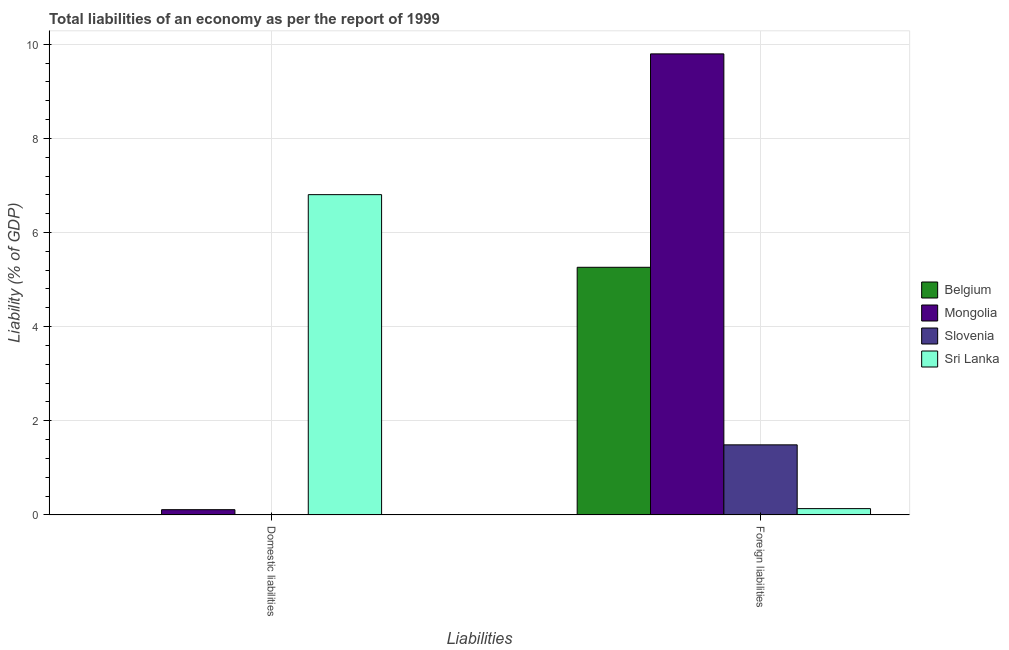How many different coloured bars are there?
Make the answer very short. 4. Are the number of bars per tick equal to the number of legend labels?
Your answer should be very brief. No. Are the number of bars on each tick of the X-axis equal?
Give a very brief answer. No. What is the label of the 1st group of bars from the left?
Provide a succinct answer. Domestic liabilities. What is the incurrence of foreign liabilities in Mongolia?
Your answer should be very brief. 9.79. Across all countries, what is the maximum incurrence of domestic liabilities?
Your response must be concise. 6.8. Across all countries, what is the minimum incurrence of domestic liabilities?
Your answer should be compact. 0. In which country was the incurrence of domestic liabilities maximum?
Keep it short and to the point. Sri Lanka. What is the total incurrence of domestic liabilities in the graph?
Your response must be concise. 6.92. What is the difference between the incurrence of foreign liabilities in Sri Lanka and that in Mongolia?
Your answer should be very brief. -9.66. What is the difference between the incurrence of foreign liabilities in Belgium and the incurrence of domestic liabilities in Slovenia?
Make the answer very short. 5.26. What is the average incurrence of foreign liabilities per country?
Give a very brief answer. 4.17. What is the difference between the incurrence of domestic liabilities and incurrence of foreign liabilities in Sri Lanka?
Your response must be concise. 6.67. In how many countries, is the incurrence of domestic liabilities greater than 9.2 %?
Ensure brevity in your answer.  0. What is the ratio of the incurrence of domestic liabilities in Mongolia to that in Sri Lanka?
Ensure brevity in your answer.  0.02. How many bars are there?
Ensure brevity in your answer.  6. Are all the bars in the graph horizontal?
Your response must be concise. No. What is the difference between two consecutive major ticks on the Y-axis?
Ensure brevity in your answer.  2. Are the values on the major ticks of Y-axis written in scientific E-notation?
Offer a terse response. No. Does the graph contain grids?
Your response must be concise. Yes. How many legend labels are there?
Your response must be concise. 4. How are the legend labels stacked?
Give a very brief answer. Vertical. What is the title of the graph?
Your response must be concise. Total liabilities of an economy as per the report of 1999. What is the label or title of the X-axis?
Your answer should be compact. Liabilities. What is the label or title of the Y-axis?
Provide a succinct answer. Liability (% of GDP). What is the Liability (% of GDP) of Mongolia in Domestic liabilities?
Ensure brevity in your answer.  0.11. What is the Liability (% of GDP) in Slovenia in Domestic liabilities?
Offer a very short reply. 0. What is the Liability (% of GDP) in Sri Lanka in Domestic liabilities?
Offer a very short reply. 6.8. What is the Liability (% of GDP) in Belgium in Foreign liabilities?
Keep it short and to the point. 5.26. What is the Liability (% of GDP) of Mongolia in Foreign liabilities?
Keep it short and to the point. 9.79. What is the Liability (% of GDP) in Slovenia in Foreign liabilities?
Keep it short and to the point. 1.49. What is the Liability (% of GDP) in Sri Lanka in Foreign liabilities?
Provide a short and direct response. 0.13. Across all Liabilities, what is the maximum Liability (% of GDP) of Belgium?
Your answer should be very brief. 5.26. Across all Liabilities, what is the maximum Liability (% of GDP) in Mongolia?
Your answer should be very brief. 9.79. Across all Liabilities, what is the maximum Liability (% of GDP) in Slovenia?
Ensure brevity in your answer.  1.49. Across all Liabilities, what is the maximum Liability (% of GDP) in Sri Lanka?
Make the answer very short. 6.8. Across all Liabilities, what is the minimum Liability (% of GDP) of Belgium?
Your response must be concise. 0. Across all Liabilities, what is the minimum Liability (% of GDP) of Mongolia?
Give a very brief answer. 0.11. Across all Liabilities, what is the minimum Liability (% of GDP) of Sri Lanka?
Provide a short and direct response. 0.13. What is the total Liability (% of GDP) in Belgium in the graph?
Your answer should be very brief. 5.26. What is the total Liability (% of GDP) of Mongolia in the graph?
Provide a succinct answer. 9.91. What is the total Liability (% of GDP) in Slovenia in the graph?
Offer a terse response. 1.49. What is the total Liability (% of GDP) of Sri Lanka in the graph?
Offer a terse response. 6.94. What is the difference between the Liability (% of GDP) in Mongolia in Domestic liabilities and that in Foreign liabilities?
Keep it short and to the point. -9.68. What is the difference between the Liability (% of GDP) of Sri Lanka in Domestic liabilities and that in Foreign liabilities?
Keep it short and to the point. 6.67. What is the difference between the Liability (% of GDP) in Mongolia in Domestic liabilities and the Liability (% of GDP) in Slovenia in Foreign liabilities?
Provide a short and direct response. -1.38. What is the difference between the Liability (% of GDP) of Mongolia in Domestic liabilities and the Liability (% of GDP) of Sri Lanka in Foreign liabilities?
Keep it short and to the point. -0.02. What is the average Liability (% of GDP) in Belgium per Liabilities?
Ensure brevity in your answer.  2.63. What is the average Liability (% of GDP) in Mongolia per Liabilities?
Offer a very short reply. 4.95. What is the average Liability (% of GDP) of Slovenia per Liabilities?
Your response must be concise. 0.74. What is the average Liability (% of GDP) of Sri Lanka per Liabilities?
Offer a terse response. 3.47. What is the difference between the Liability (% of GDP) in Mongolia and Liability (% of GDP) in Sri Lanka in Domestic liabilities?
Make the answer very short. -6.69. What is the difference between the Liability (% of GDP) in Belgium and Liability (% of GDP) in Mongolia in Foreign liabilities?
Your response must be concise. -4.53. What is the difference between the Liability (% of GDP) in Belgium and Liability (% of GDP) in Slovenia in Foreign liabilities?
Provide a succinct answer. 3.77. What is the difference between the Liability (% of GDP) of Belgium and Liability (% of GDP) of Sri Lanka in Foreign liabilities?
Provide a short and direct response. 5.13. What is the difference between the Liability (% of GDP) of Mongolia and Liability (% of GDP) of Slovenia in Foreign liabilities?
Your answer should be compact. 8.31. What is the difference between the Liability (% of GDP) in Mongolia and Liability (% of GDP) in Sri Lanka in Foreign liabilities?
Your response must be concise. 9.66. What is the difference between the Liability (% of GDP) of Slovenia and Liability (% of GDP) of Sri Lanka in Foreign liabilities?
Give a very brief answer. 1.35. What is the ratio of the Liability (% of GDP) in Mongolia in Domestic liabilities to that in Foreign liabilities?
Provide a succinct answer. 0.01. What is the ratio of the Liability (% of GDP) of Sri Lanka in Domestic liabilities to that in Foreign liabilities?
Provide a short and direct response. 50.71. What is the difference between the highest and the second highest Liability (% of GDP) in Mongolia?
Ensure brevity in your answer.  9.68. What is the difference between the highest and the second highest Liability (% of GDP) of Sri Lanka?
Your answer should be compact. 6.67. What is the difference between the highest and the lowest Liability (% of GDP) in Belgium?
Make the answer very short. 5.26. What is the difference between the highest and the lowest Liability (% of GDP) of Mongolia?
Provide a short and direct response. 9.68. What is the difference between the highest and the lowest Liability (% of GDP) of Slovenia?
Keep it short and to the point. 1.49. What is the difference between the highest and the lowest Liability (% of GDP) in Sri Lanka?
Your answer should be very brief. 6.67. 